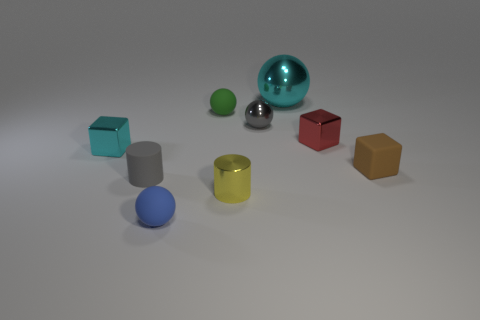Does the gray ball have the same size as the blue object?
Your answer should be compact. Yes. How many other objects are there of the same shape as the red object?
Keep it short and to the point. 2. What material is the blue object that is in front of the ball that is on the right side of the small gray metallic object?
Offer a very short reply. Rubber. Are there any small things left of the matte block?
Offer a very short reply. Yes. There is a green matte object; does it have the same size as the cyan metallic thing that is right of the blue object?
Offer a terse response. No. What is the size of the cyan shiny object that is the same shape as the tiny green object?
Make the answer very short. Large. There is a ball behind the green rubber sphere; is it the same size as the rubber sphere behind the small brown rubber object?
Give a very brief answer. No. What number of small things are gray shiny spheres or brown rubber blocks?
Ensure brevity in your answer.  2. How many tiny rubber objects are both behind the yellow object and in front of the brown object?
Make the answer very short. 1. Do the tiny brown cube and the ball in front of the gray rubber cylinder have the same material?
Your answer should be very brief. Yes. 